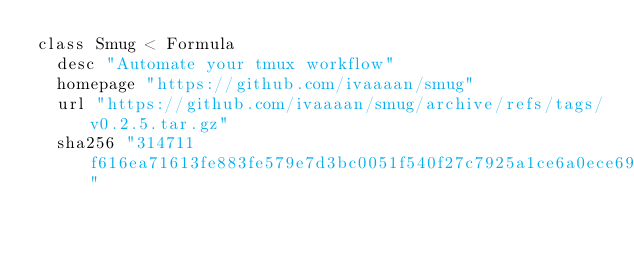Convert code to text. <code><loc_0><loc_0><loc_500><loc_500><_Ruby_>class Smug < Formula
  desc "Automate your tmux workflow"
  homepage "https://github.com/ivaaaan/smug"
  url "https://github.com/ivaaaan/smug/archive/refs/tags/v0.2.5.tar.gz"
  sha256 "314711f616ea71613fe883fe579e7d3bc0051f540f27c7925a1ce6a0ece69378"</code> 